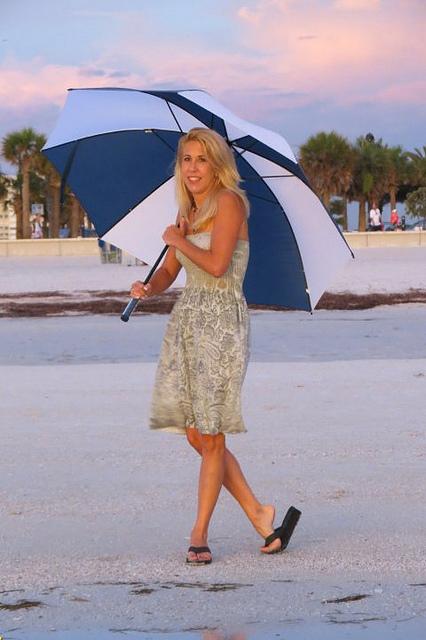Is the woman wearing a bathing suit?
Give a very brief answer. No. What color is her hair?
Answer briefly. Blonde. Is the woman walking at the park?
Write a very short answer. No. 